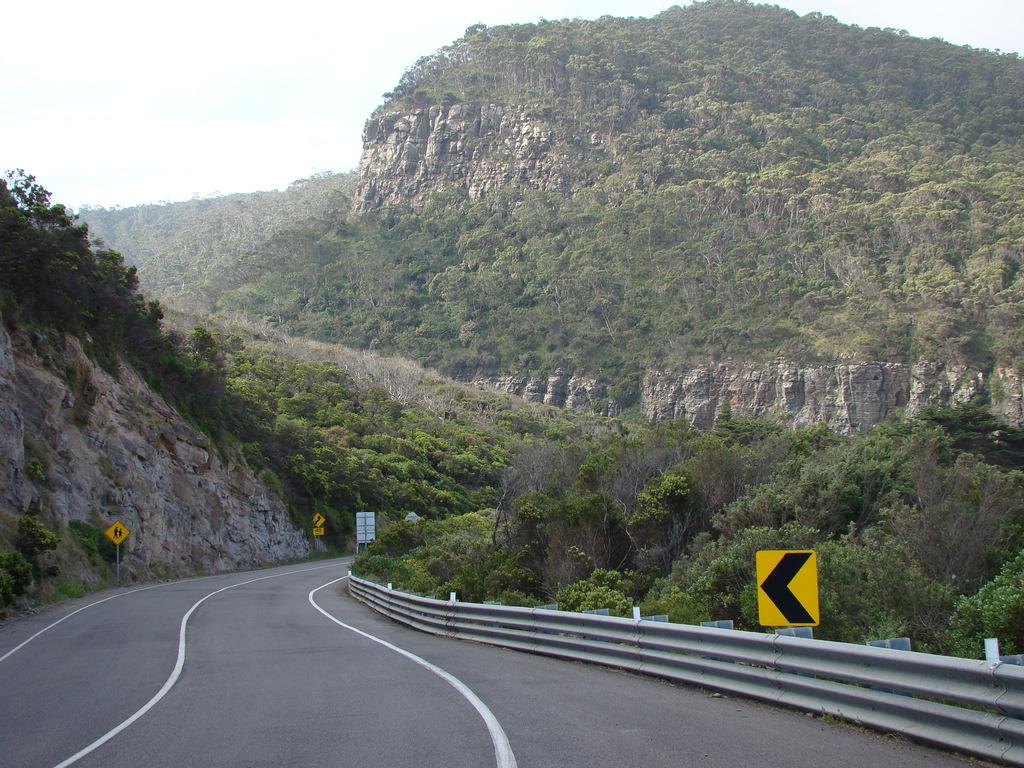What is the main feature of the image? There is a road in the image. What can be seen on the right side of the image? There is a railing and a yellow color board on the right side of the image. What type of vegetation is visible in the image? There are trees visible in the image. What is visible in the background of the image? There is a hill and the sky visible in the background of the image. What type of shoe can be seen hanging from the trees in the image? There are no shoes visible in the image; only a road, railing, yellow color board, trees, a hill, and the sky are present. Is there any eggnog being served in the image? There is no mention of eggnog or any food or drink in the image. 